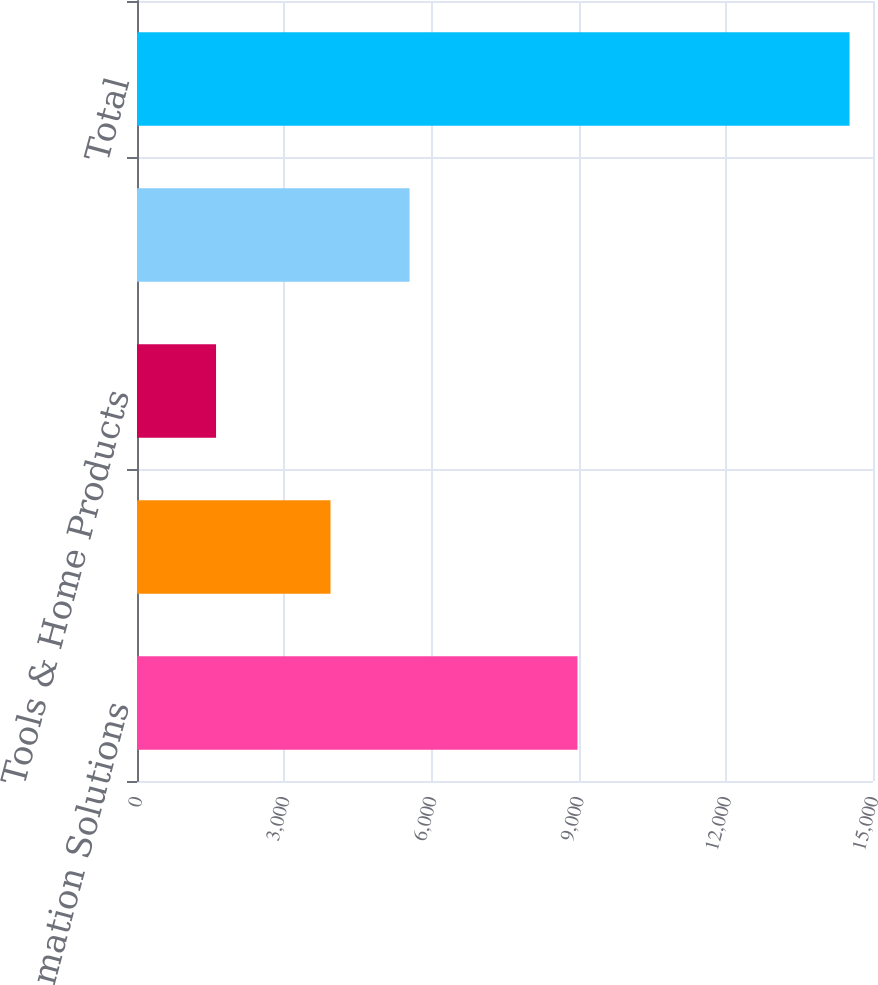Convert chart. <chart><loc_0><loc_0><loc_500><loc_500><bar_chart><fcel>Automation Solutions<fcel>Climate Technologies<fcel>Tools & Home Products<fcel>Residential Solutions<fcel>Total<nl><fcel>8977<fcel>3944<fcel>1611<fcel>5555<fcel>14522<nl></chart> 